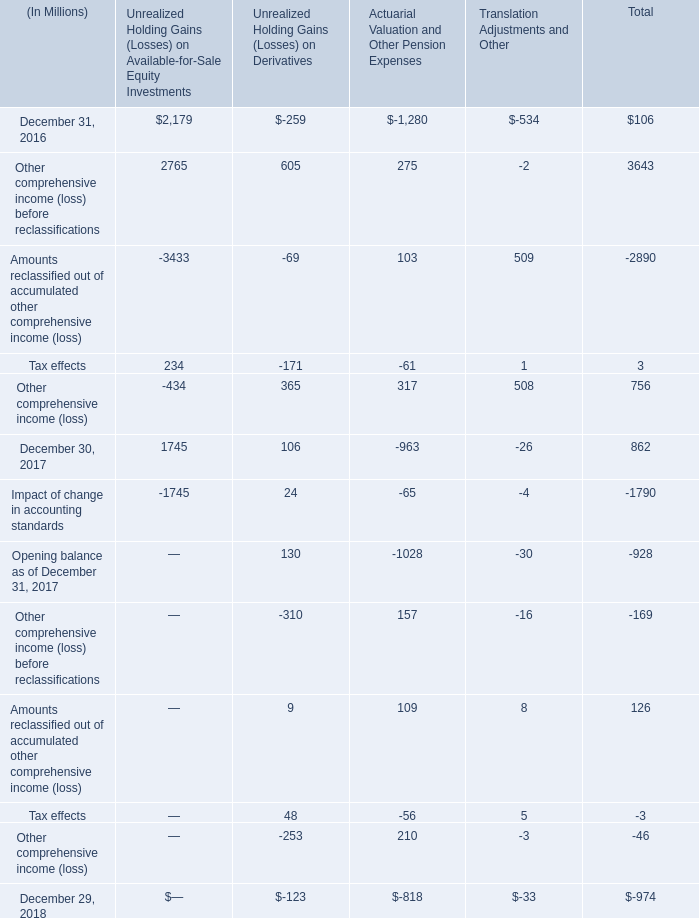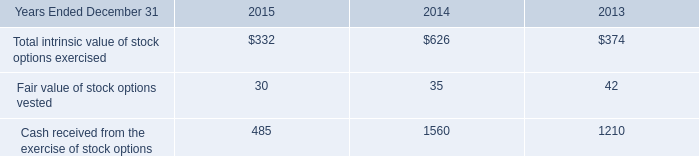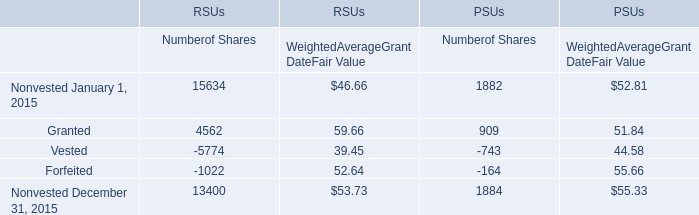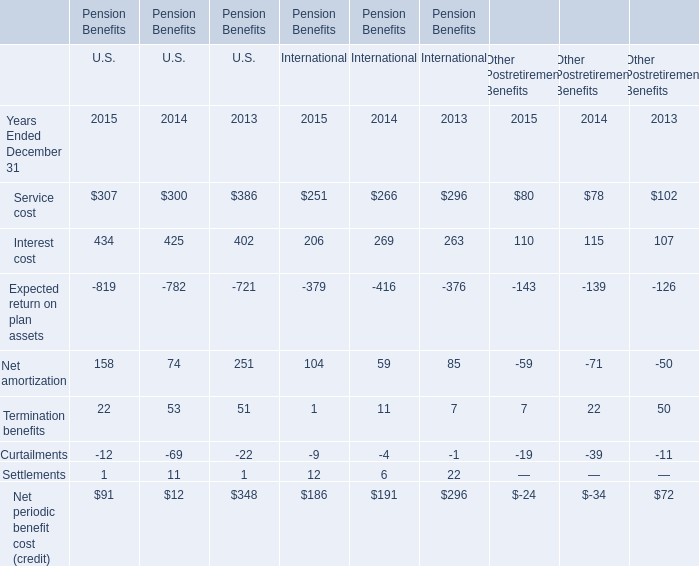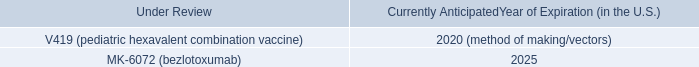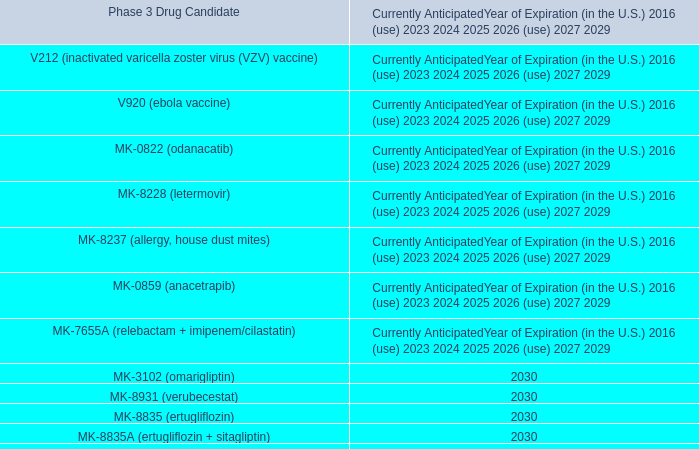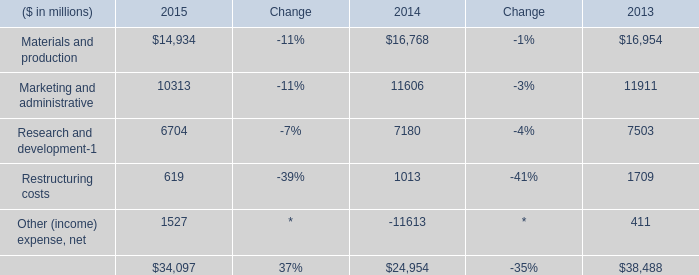What is the ratio of all Numberof Shares that are smaller than 0 to the sum of Numberof Shares, in 2015 for PSUs? 
Computations: ((-743 - 164) / ((((1882 + 909) - 743) - 164) + 1884))
Answer: -0.24071. 